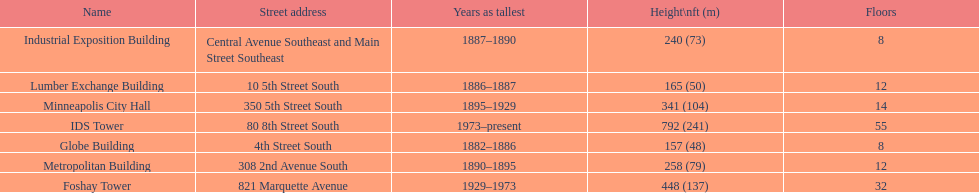Name the tallest building. IDS Tower. 